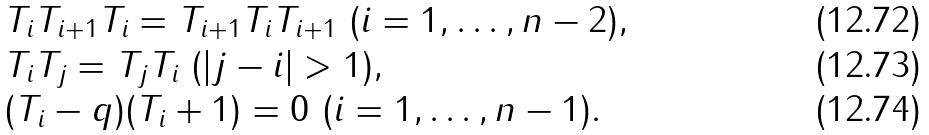<formula> <loc_0><loc_0><loc_500><loc_500>& T _ { i } T _ { i + 1 } T _ { i } = T _ { i + 1 } T _ { i } T _ { i + 1 } \ ( i = 1 , \dots , n - 2 ) , \\ & T _ { i } T _ { j } = T _ { j } T _ { i } \ ( | j - i | > 1 ) , \\ & ( T _ { i } - q ) ( T _ { i } + 1 ) = 0 \ ( i = 1 , \dots , n - 1 ) .</formula> 